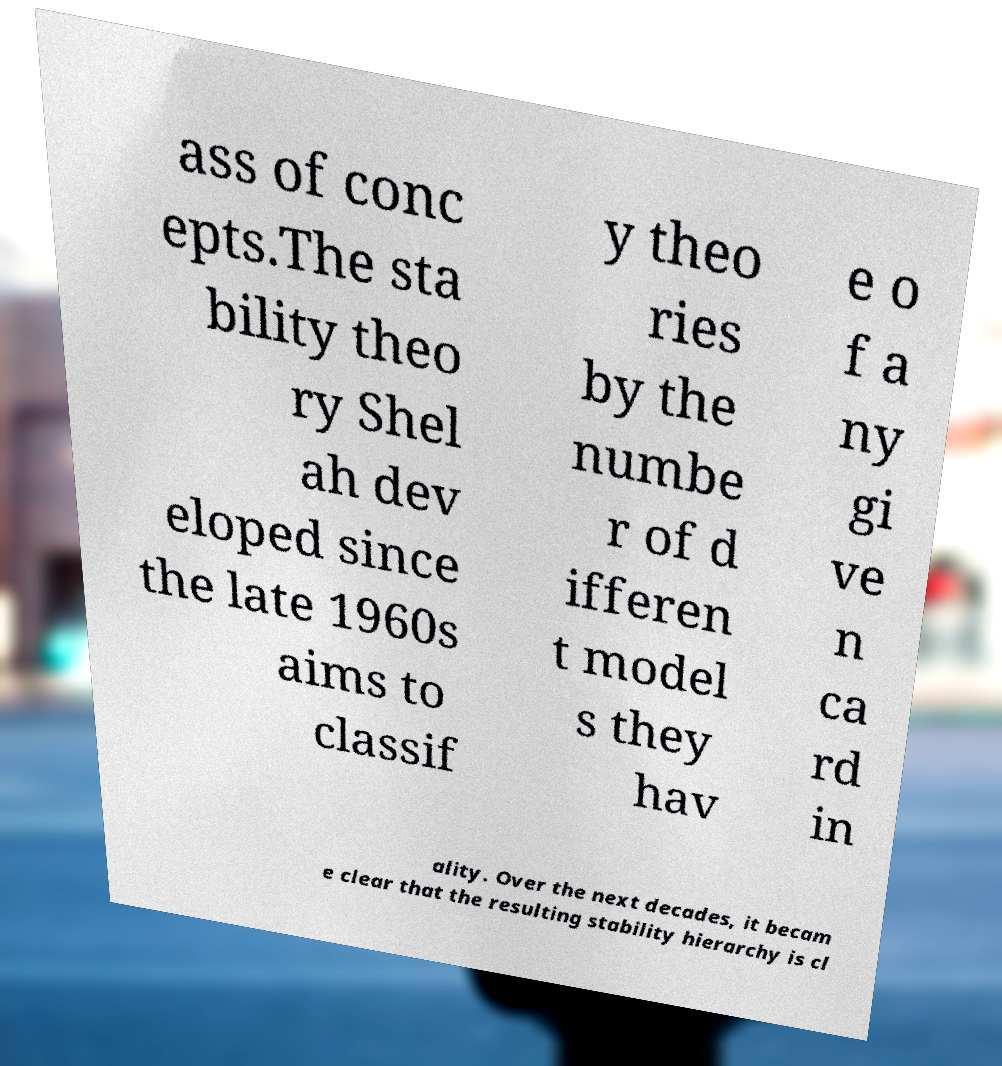For documentation purposes, I need the text within this image transcribed. Could you provide that? ass of conc epts.The sta bility theo ry Shel ah dev eloped since the late 1960s aims to classif y theo ries by the numbe r of d ifferen t model s they hav e o f a ny gi ve n ca rd in ality. Over the next decades, it becam e clear that the resulting stability hierarchy is cl 